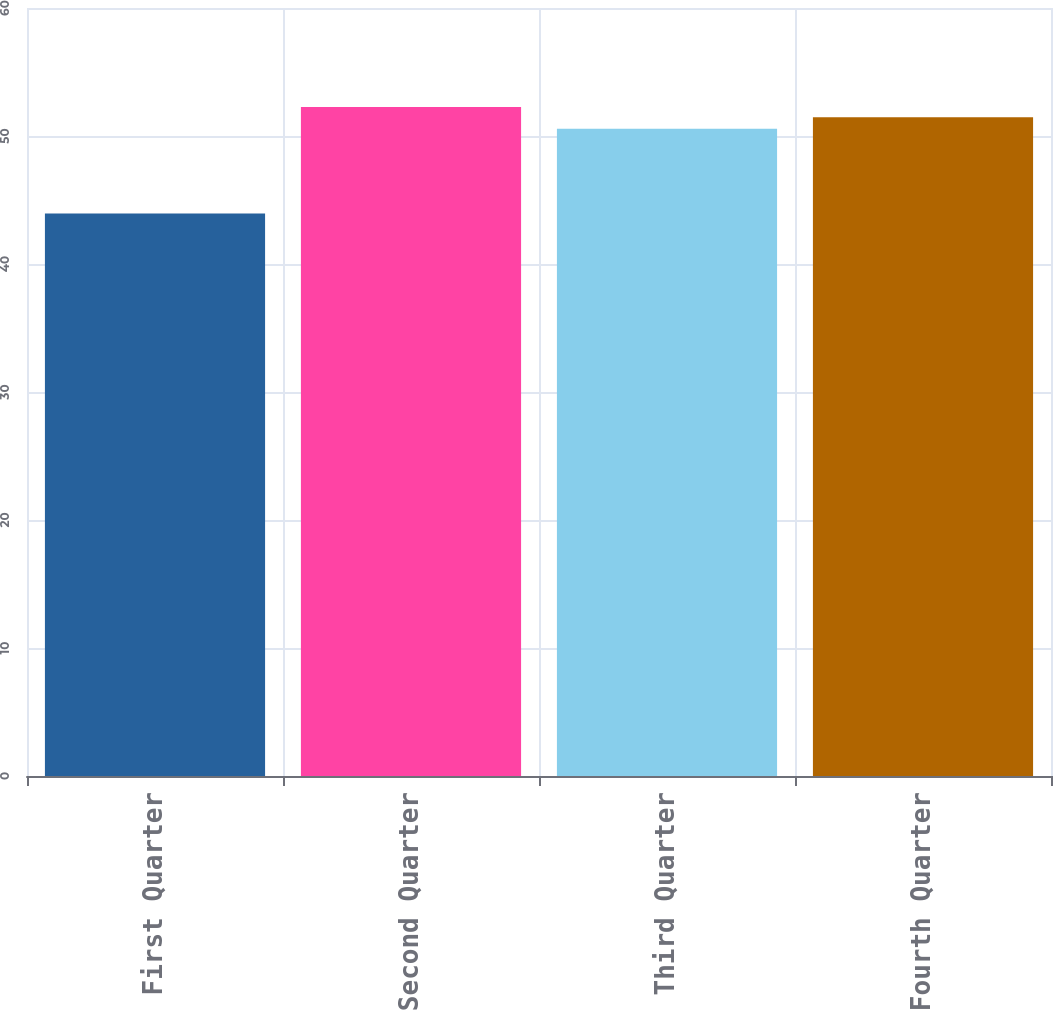Convert chart to OTSL. <chart><loc_0><loc_0><loc_500><loc_500><bar_chart><fcel>First Quarter<fcel>Second Quarter<fcel>Third Quarter<fcel>Fourth Quarter<nl><fcel>43.94<fcel>52.26<fcel>50.56<fcel>51.47<nl></chart> 